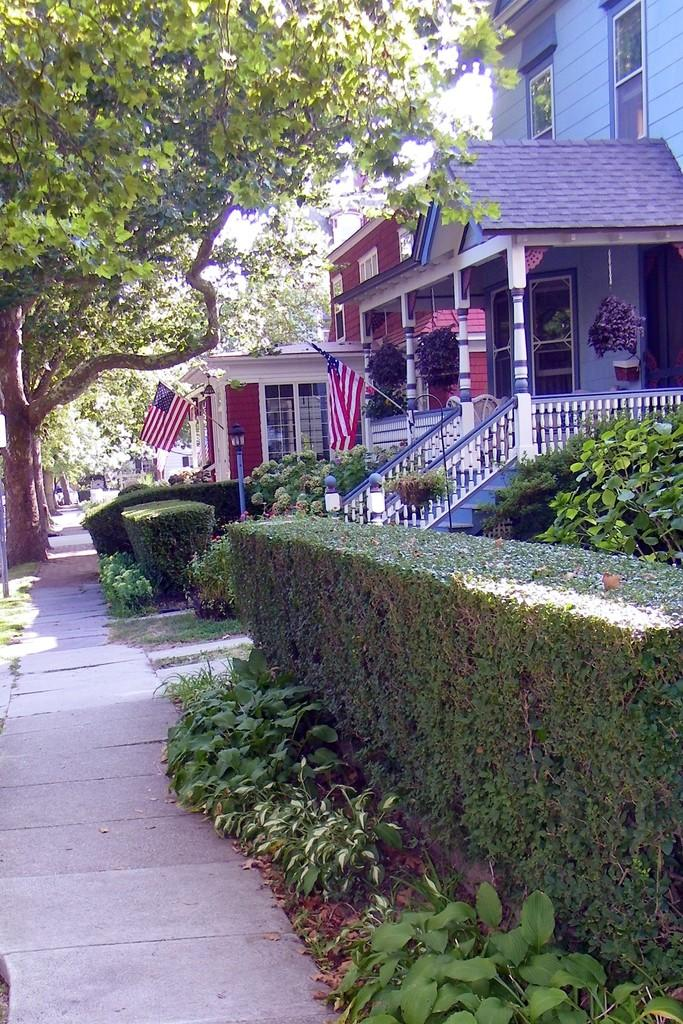What type of structures can be seen in the image? There are houses in the image. What is one feature of the houses in the image? There is a wall in the image. What type of window is present in the image? There is a glass window in the image. What type of vegetation is visible in the image? There are plants in the image. What type of vertical structures are present in the image? There are poles in the image. What type of decorative or symbolic objects are present in the image? There are flags in the image. What type of illumination is present in the image? There is a light in the image. What type of natural features are visible in the image? There are trees in the image. What type of path is present at the bottom of the image? There is a walkway at the bottom of the image. What type of trousers are being worn by the trees in the image? There are no trousers present in the image, as trees do not wear clothing. What type of haircut is being sported by the light in the image? There is no hair present in the image, as lights do not have hair. 